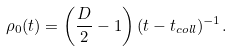<formula> <loc_0><loc_0><loc_500><loc_500>\rho _ { 0 } ( t ) = \left ( \frac { D } { 2 } - 1 \right ) ( t - t _ { c o l l } ) ^ { - 1 } .</formula> 